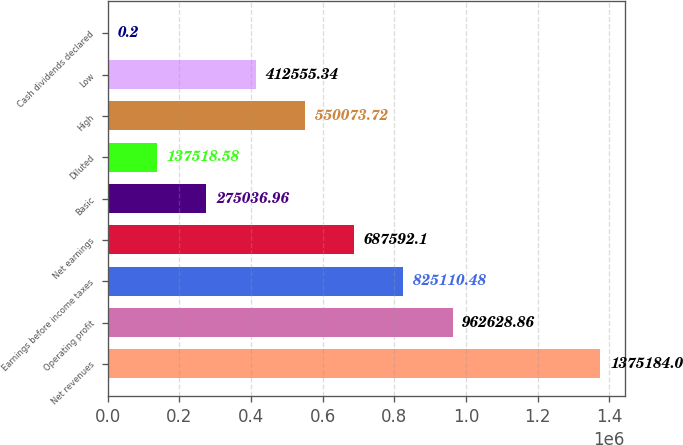Convert chart to OTSL. <chart><loc_0><loc_0><loc_500><loc_500><bar_chart><fcel>Net revenues<fcel>Operating profit<fcel>Earnings before income taxes<fcel>Net earnings<fcel>Basic<fcel>Diluted<fcel>High<fcel>Low<fcel>Cash dividends declared<nl><fcel>1.37518e+06<fcel>962629<fcel>825110<fcel>687592<fcel>275037<fcel>137519<fcel>550074<fcel>412555<fcel>0.2<nl></chart> 